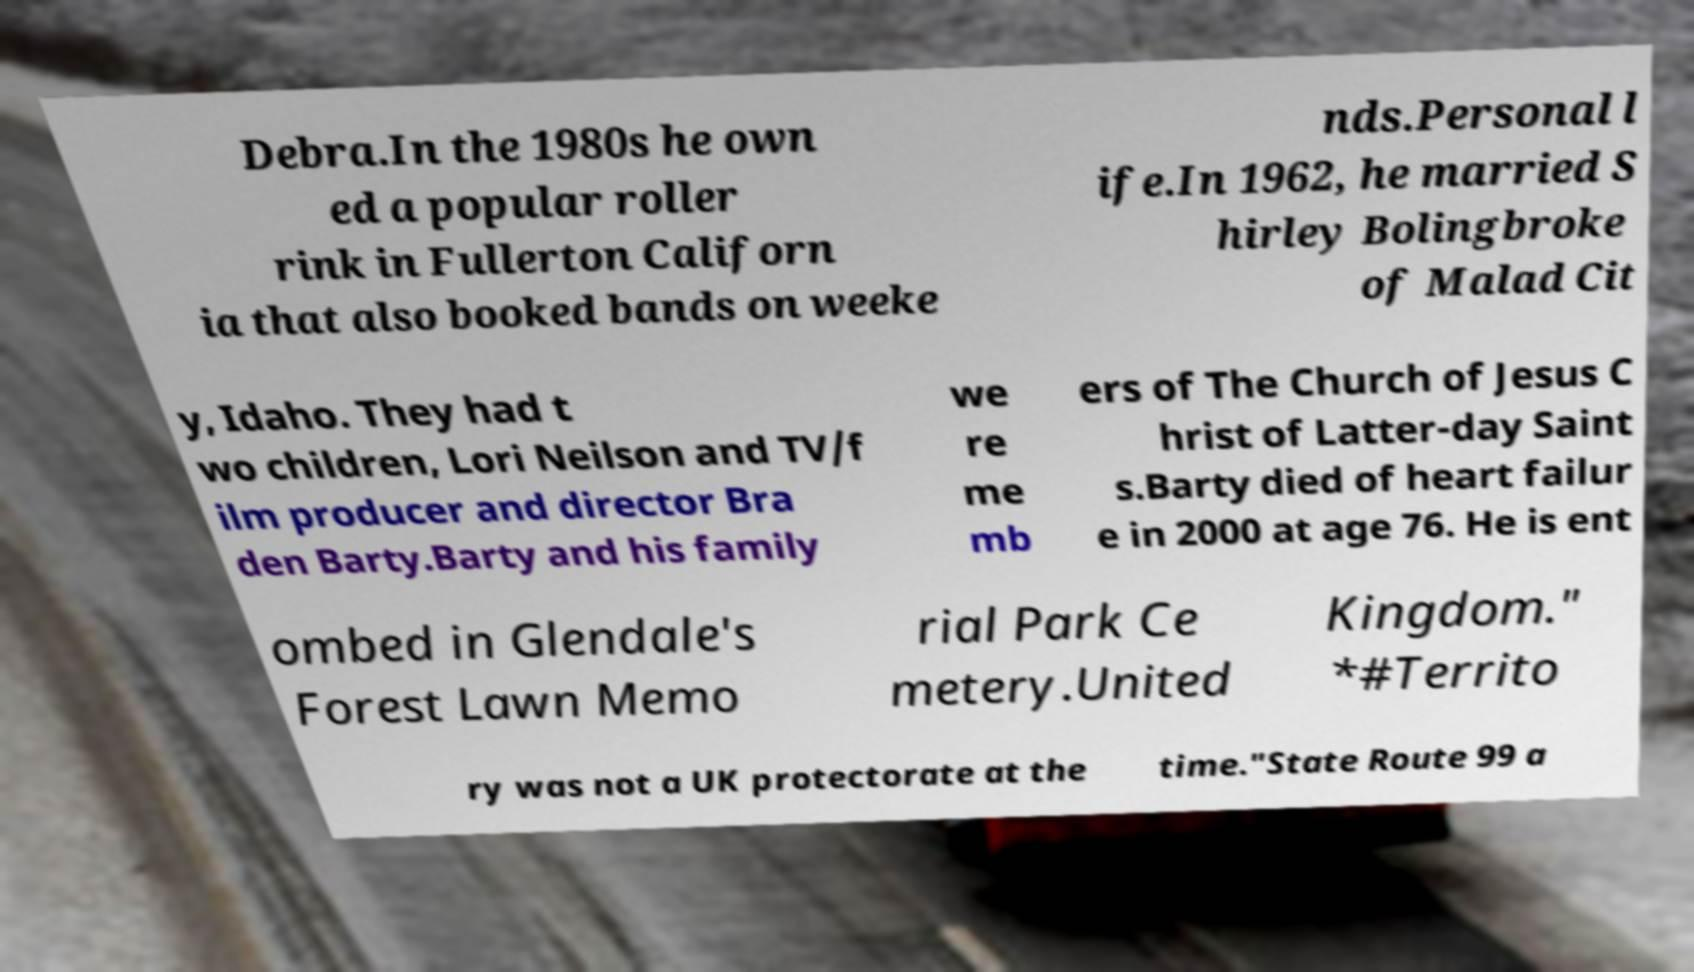Please identify and transcribe the text found in this image. Debra.In the 1980s he own ed a popular roller rink in Fullerton Californ ia that also booked bands on weeke nds.Personal l ife.In 1962, he married S hirley Bolingbroke of Malad Cit y, Idaho. They had t wo children, Lori Neilson and TV/f ilm producer and director Bra den Barty.Barty and his family we re me mb ers of The Church of Jesus C hrist of Latter-day Saint s.Barty died of heart failur e in 2000 at age 76. He is ent ombed in Glendale's Forest Lawn Memo rial Park Ce metery.United Kingdom." *#Territo ry was not a UK protectorate at the time."State Route 99 a 